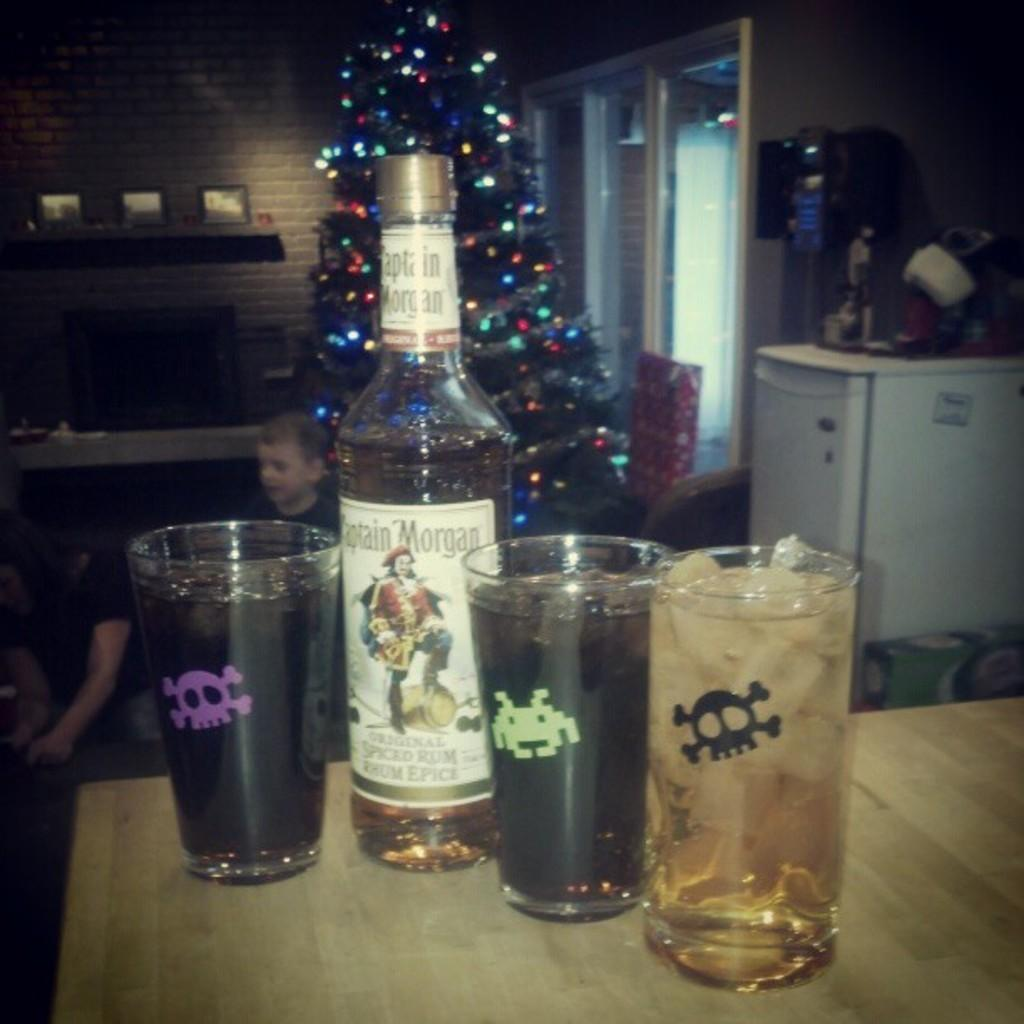<image>
Write a terse but informative summary of the picture. four glasses of alcohol and a bottle of Captain Morgan next to them on the table. 